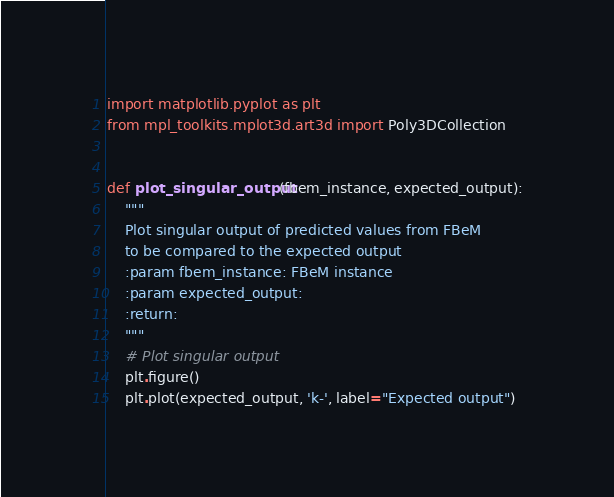<code> <loc_0><loc_0><loc_500><loc_500><_Python_>import matplotlib.pyplot as plt
from mpl_toolkits.mplot3d.art3d import Poly3DCollection


def plot_singular_output(fbem_instance, expected_output):
    """
    Plot singular output of predicted values from FBeM
    to be compared to the expected output
    :param fbem_instance: FBeM instance
    :param expected_output:
    :return:
    """
    # Plot singular output
    plt.figure()
    plt.plot(expected_output, 'k-', label="Expected output")</code> 